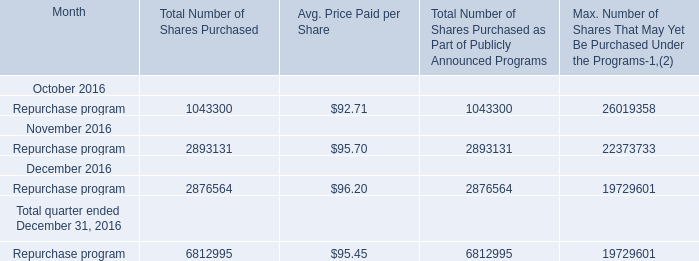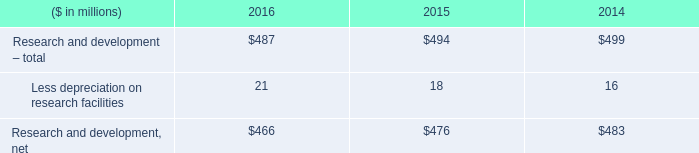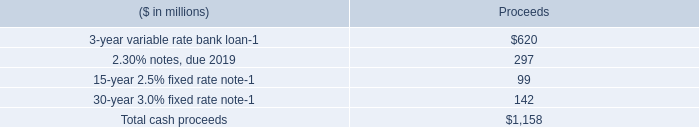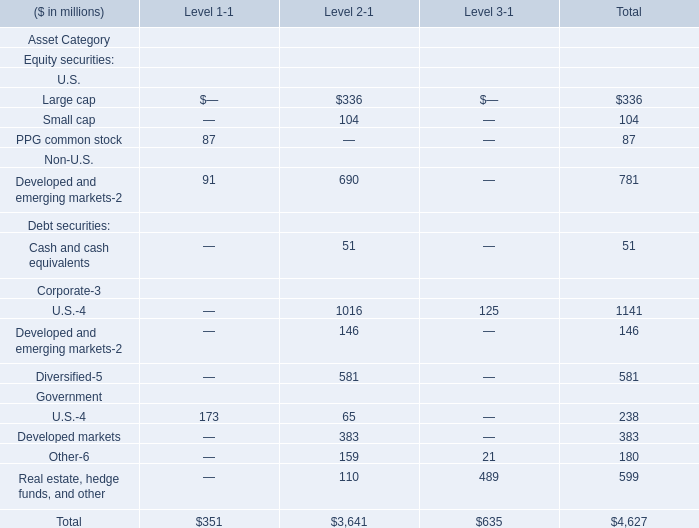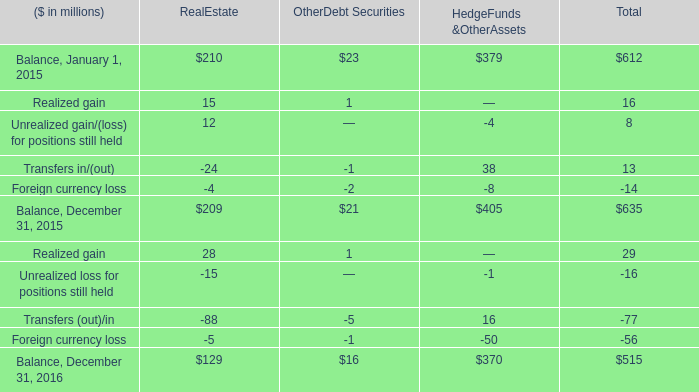what was the percentage change in research and development net from 2014 to 2015? 
Computations: ((476 - 483) / 483)
Answer: -0.01449. 